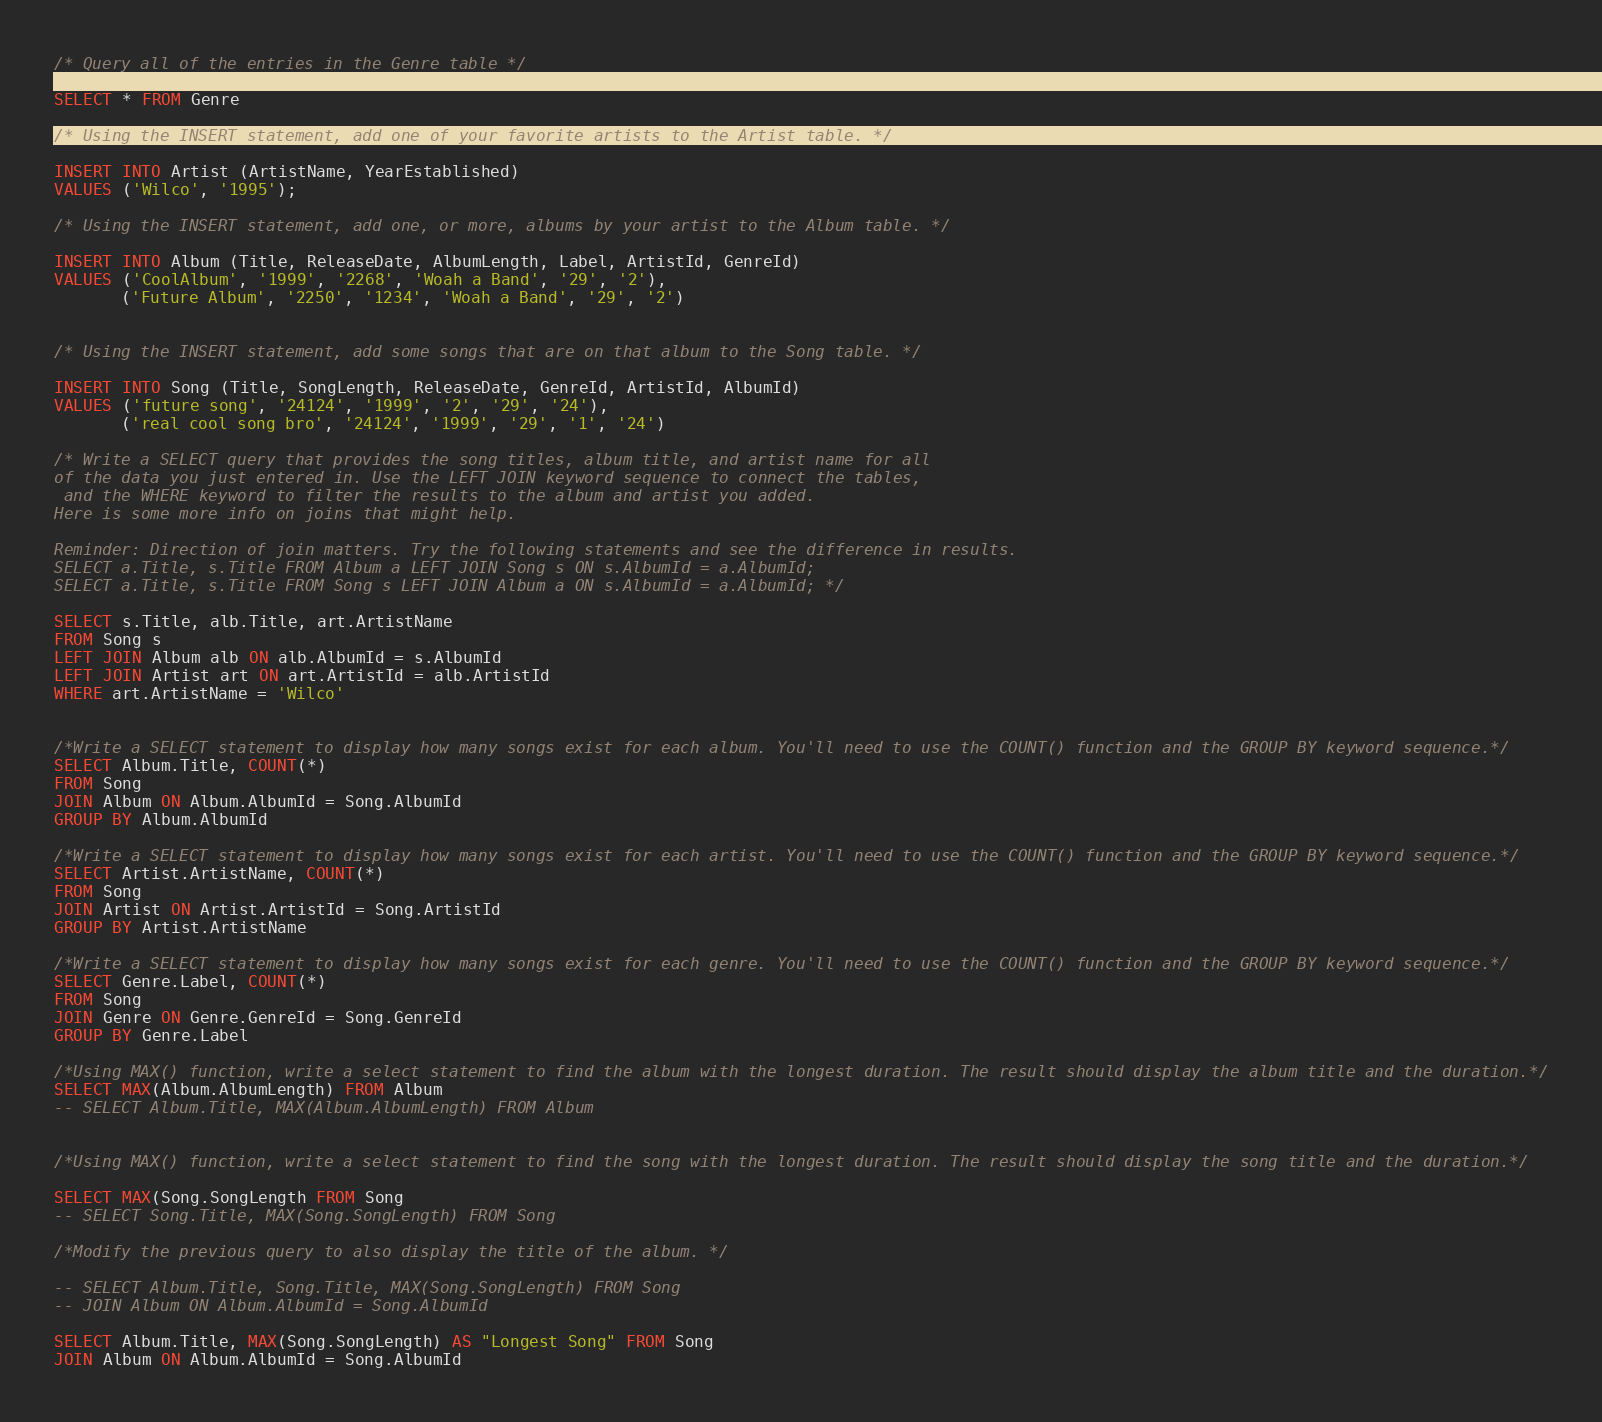<code> <loc_0><loc_0><loc_500><loc_500><_SQL_>/* Query all of the entries in the Genre table */

SELECT * FROM Genre

/* Using the INSERT statement, add one of your favorite artists to the Artist table. */

INSERT INTO Artist (ArtistName, YearEstablished)
VALUES ('Wilco', '1995');

/* Using the INSERT statement, add one, or more, albums by your artist to the Album table. */

INSERT INTO Album (Title, ReleaseDate, AlbumLength, Label, ArtistId, GenreId)
VALUES ('CoolAlbum', '1999', '2268', 'Woah a Band', '29', '2'),
       ('Future Album', '2250', '1234', 'Woah a Band', '29', '2')


/* Using the INSERT statement, add some songs that are on that album to the Song table. */

INSERT INTO Song (Title, SongLength, ReleaseDate, GenreId, ArtistId, AlbumId)
VALUES ('future song', '24124', '1999', '2', '29', '24'),
       ('real cool song bro', '24124', '1999', '29', '1', '24')

/* Write a SELECT query that provides the song titles, album title, and artist name for all
of the data you just entered in. Use the LEFT JOIN keyword sequence to connect the tables,
 and the WHERE keyword to filter the results to the album and artist you added.
Here is some more info on joins that might help.

Reminder: Direction of join matters. Try the following statements and see the difference in results.
SELECT a.Title, s.Title FROM Album a LEFT JOIN Song s ON s.AlbumId = a.AlbumId;
SELECT a.Title, s.Title FROM Song s LEFT JOIN Album a ON s.AlbumId = a.AlbumId; */

SELECT s.Title, alb.Title, art.ArtistName
FROM Song s
LEFT JOIN Album alb ON alb.AlbumId = s.AlbumId
LEFT JOIN Artist art ON art.ArtistId = alb.ArtistId
WHERE art.ArtistName = 'Wilco'


/*Write a SELECT statement to display how many songs exist for each album. You'll need to use the COUNT() function and the GROUP BY keyword sequence.*/
SELECT Album.Title, COUNT(*)
FROM Song
JOIN Album ON Album.AlbumId = Song.AlbumId
GROUP BY Album.AlbumId

/*Write a SELECT statement to display how many songs exist for each artist. You'll need to use the COUNT() function and the GROUP BY keyword sequence.*/
SELECT Artist.ArtistName, COUNT(*)
FROM Song
JOIN Artist ON Artist.ArtistId = Song.ArtistId
GROUP BY Artist.ArtistName

/*Write a SELECT statement to display how many songs exist for each genre. You'll need to use the COUNT() function and the GROUP BY keyword sequence.*/
SELECT Genre.Label, COUNT(*)
FROM Song
JOIN Genre ON Genre.GenreId = Song.GenreId
GROUP BY Genre.Label

/*Using MAX() function, write a select statement to find the album with the longest duration. The result should display the album title and the duration.*/
SELECT MAX(Album.AlbumLength) FROM Album
-- SELECT Album.Title, MAX(Album.AlbumLength) FROM Album


/*Using MAX() function, write a select statement to find the song with the longest duration. The result should display the song title and the duration.*/

SELECT MAX(Song.SongLength FROM Song
-- SELECT Song.Title, MAX(Song.SongLength) FROM Song

/*Modify the previous query to also display the title of the album. */

-- SELECT Album.Title, Song.Title, MAX(Song.SongLength) FROM Song
-- JOIN Album ON Album.AlbumId = Song.AlbumId

SELECT Album.Title, MAX(Song.SongLength) AS "Longest Song" FROM Song
JOIN Album ON Album.AlbumId = Song.AlbumId
</code> 